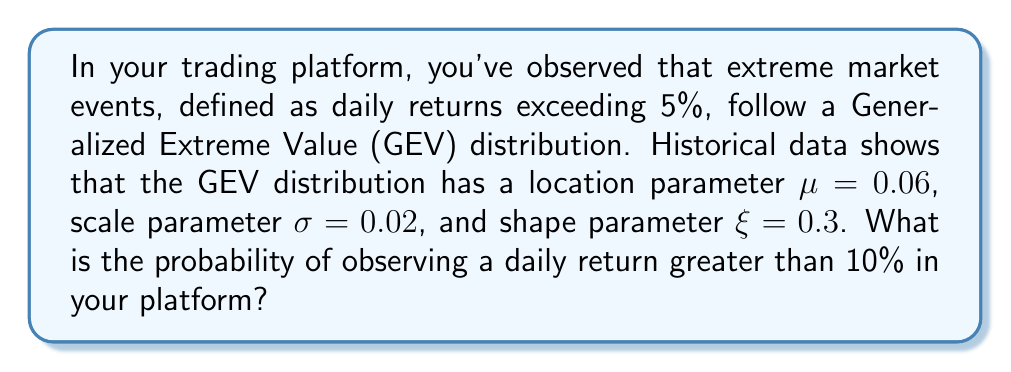What is the answer to this math problem? To solve this problem, we'll use the Generalized Extreme Value (GEV) distribution and its cumulative distribution function (CDF).

Step 1: Recall the CDF of the GEV distribution:
$$F(x; \mu, \sigma, \xi) = \exp\left\{-\left[1 + \xi\left(\frac{x-\mu}{\sigma}\right)\right]^{-1/\xi}\right\}$$
where $\mu$ is the location parameter, $\sigma$ is the scale parameter, and $\xi$ is the shape parameter.

Step 2: We want to find $P(X > 0.10)$, which is equal to $1 - P(X \leq 0.10)$. So, we need to calculate:
$$1 - F(0.10; 0.06, 0.02, 0.3)$$

Step 3: Let's substitute the values into the CDF formula:
$$1 - \exp\left\{-\left[1 + 0.3\left(\frac{0.10-0.06}{0.02}\right)\right]^{-1/0.3}\right\}$$

Step 4: Simplify the expression inside the parentheses:
$$1 - \exp\left\{-\left[1 + 0.3\left(\frac{0.04}{0.02}\right)\right]^{-1/0.3}\right\}$$
$$1 - \exp\left\{-\left[1 + 0.3(2)\right]^{-1/0.3}\right\}$$
$$1 - \exp\left\{-\left[1.6\right]^{-1/0.3}\right\}$$

Step 5: Calculate the exponent:
$$1 - \exp\left\{-\left[1.6\right]^{-3.333...}\right\}$$
$$1 - \exp\left\{-0.244...\right\}$$

Step 6: Evaluate the final expression:
$$1 - 0.783... = 0.217...$$

Therefore, the probability of observing a daily return greater than 10% is approximately 0.217 or 21.7%.
Answer: 0.217 